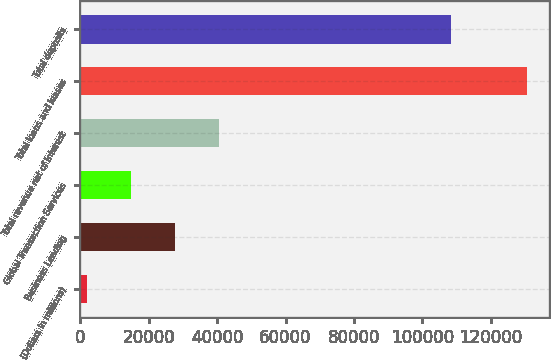Convert chart to OTSL. <chart><loc_0><loc_0><loc_500><loc_500><bar_chart><fcel>(Dollars in millions)<fcel>Business Lending<fcel>Global Transaction Services<fcel>Total revenue net of interest<fcel>Total loans and leases<fcel>Total deposits<nl><fcel>2013<fcel>27731.6<fcel>14872.3<fcel>40590.9<fcel>130606<fcel>108532<nl></chart> 